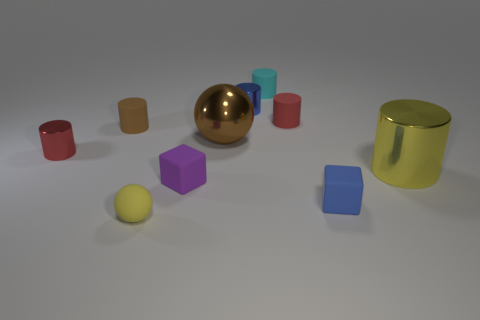What color is the rubber sphere that is the same size as the brown rubber thing?
Make the answer very short. Yellow. What number of red things are either tiny things or big cylinders?
Ensure brevity in your answer.  2. Are there more brown shiny things than cylinders?
Give a very brief answer. No. There is a cylinder to the left of the brown matte thing; is its size the same as the yellow object to the left of the small blue rubber thing?
Offer a very short reply. Yes. What color is the shiny object that is in front of the metallic cylinder that is left of the cube left of the brown sphere?
Offer a very short reply. Yellow. Is there a small yellow rubber object that has the same shape as the large brown metal object?
Offer a very short reply. Yes. Is the number of cyan objects on the right side of the brown rubber object greater than the number of green things?
Make the answer very short. Yes. How many matte objects are either small blue objects or cyan objects?
Offer a terse response. 2. What size is the cylinder that is both to the right of the brown ball and in front of the large brown object?
Provide a succinct answer. Large. There is a shiny cylinder that is on the left side of the brown metal ball; are there any small red cylinders on the right side of it?
Give a very brief answer. Yes. 